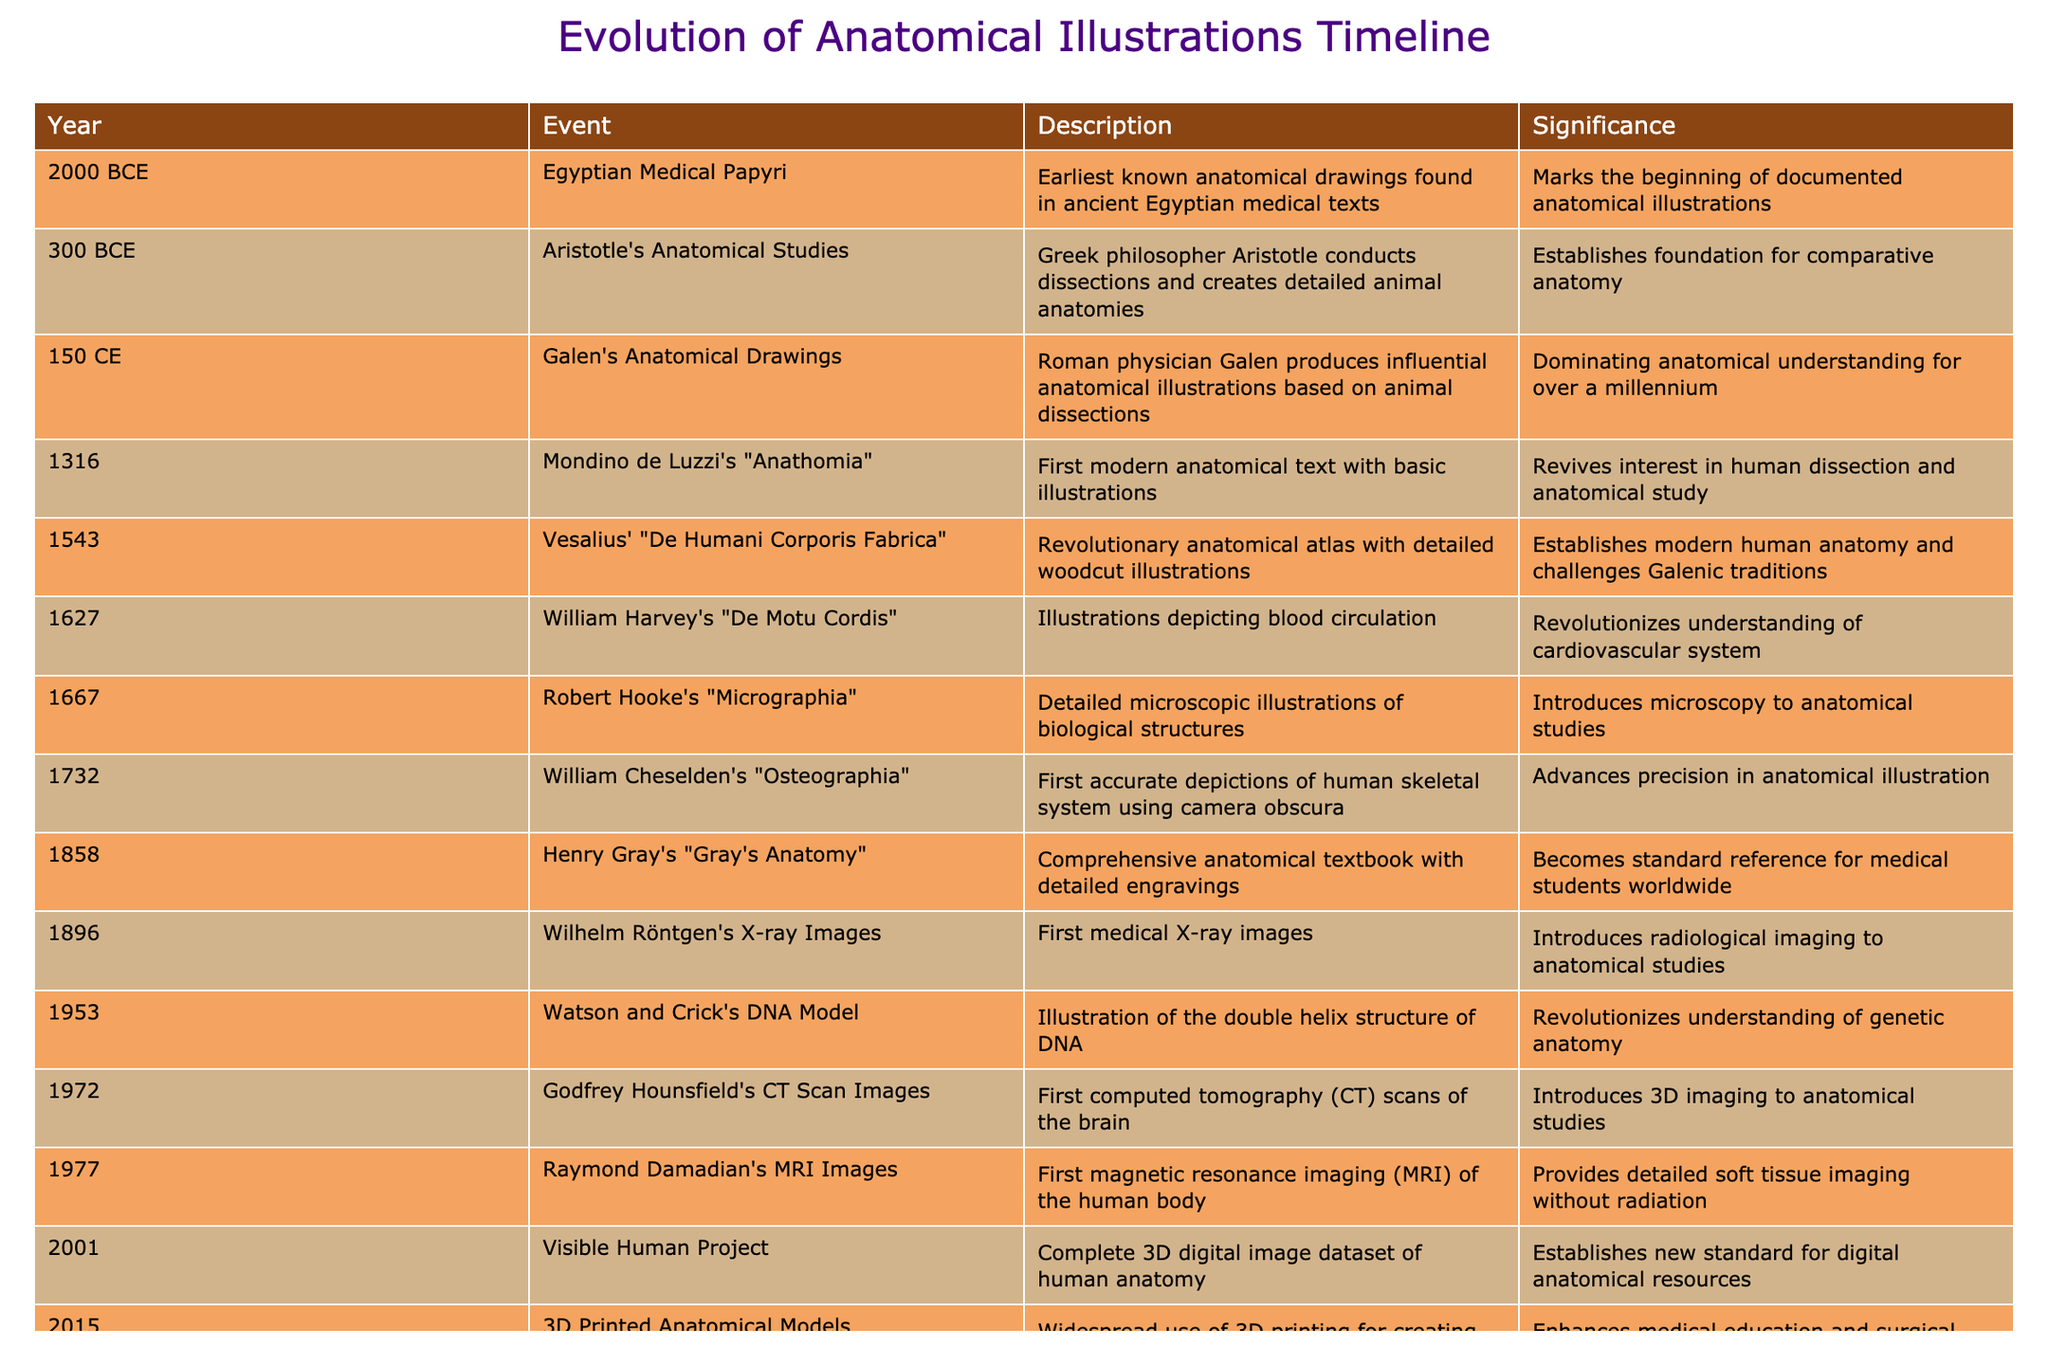What year did Galen produce his anatomical illustrations? According to the timeline, Galen's anatomical drawings were produced in the year 150 CE. This is directly stated in the "Year" column corresponding to the event description.
Answer: 150 CE Which event marks the beginning of documented anatomical illustrations? The earliest known anatomical drawings, found in the Egyptian Medical Papyri dated to 2000 BCE, mark the beginning of documented anatomical illustrations. This is confirmed by the significance noted in the table.
Answer: Egyptian Medical Papyri How many years are between the creation of the first modern anatomical text and Vesalius' revolutionary atlas? Mondino de Luzzi's "Anathomia" was created in 1316 and Vesalius' "De Humani Corporis Fabrica" was published in 1543. The difference in years is 1543 - 1316 = 227 years.
Answer: 227 years Did Robert Hooke introduce microscopy to anatomical studies? Yes, Robert Hooke's work, "Micrographia," published in 1667, is noted for detailed microscopic illustrations that introduced microscopy to anatomical studies. This is explicitly stated in the description of the event.
Answer: Yes Which two publications brought significant conceptual advancements to the understanding of human anatomy in the 16th and 17th centuries? In the 16th century, Vesalius' "De Humani Corporis Fabrica" (1543) revolutionized human anatomy, and in the 17th century, William Harvey's "De Motu Cordis" (1627) illustrated blood circulation. Both events indicate substantial advancements in anatomical knowledge addressing human anatomy and physiology.
Answer: Vesalius' "De Humani Corporis Fabrica" and Harvey's "De Motu Cordis" What is the significance of the year 2001 in the evolution of anatomical resources? The year 2001 marks the introduction of the Visible Human Project, which provided a complete 3D digital image dataset of human anatomy, establishing a new standard for digital anatomical resources. This is summarized in the table's significance section.
Answer: Establishes new standard for digital anatomical resources How many events listed in the table occurred after 1800? Looking through the table, the events that occurred after 1800 are: Henry Gray's "Gray's Anatomy" (1858), Wilhelm Röntgen's X-ray images (1896), Watson and Crick's DNA model (1953), Godfrey Hounsfield's CT scan images (1972), Raymond Damadian's MRI images (1977), the Visible Human Project (2001), and 3D printed anatomical models (2015). This results in a total of 7 events.
Answer: 7 events Was the first magnetic resonance imaging (MRI) of the human body created before the first computed tomography (CT) scans? No, the first CT scans were introduced by Godfrey Hounsfield in 1972, while the first MRI images were produced by Raymond Damadian in 1977. Therefore, the MRI followed the CT scans.
Answer: No What are the notable advancements in imaging techniques mentioned in the timeline, and in which years did they occur? The notable advancements in imaging techniques mentioned are: Wilhelm Röntgen's first medical X-ray images in 1896, Godfrey Hounsfield's first computed tomography (CT) scans in 1972, and Raymond Damadian's first magnetic resonance imaging (MRI) in 1977. These three events represent significant milestones in anatomical illustration technology.
Answer: X-ray: 1896; CT: 1972; MRI: 1977 